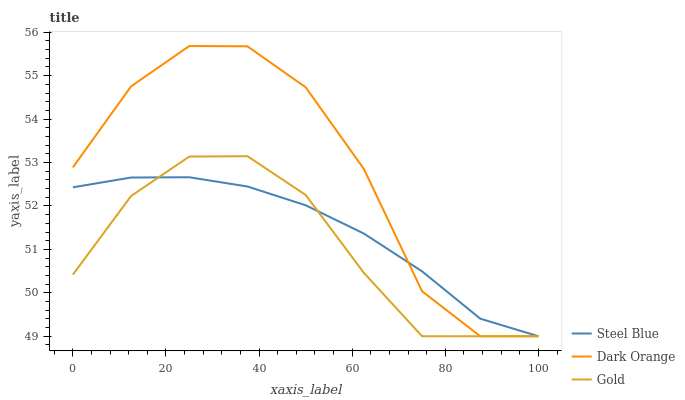Does Gold have the minimum area under the curve?
Answer yes or no. Yes. Does Dark Orange have the maximum area under the curve?
Answer yes or no. Yes. Does Steel Blue have the minimum area under the curve?
Answer yes or no. No. Does Steel Blue have the maximum area under the curve?
Answer yes or no. No. Is Steel Blue the smoothest?
Answer yes or no. Yes. Is Dark Orange the roughest?
Answer yes or no. Yes. Is Gold the smoothest?
Answer yes or no. No. Is Gold the roughest?
Answer yes or no. No. Does Dark Orange have the lowest value?
Answer yes or no. Yes. Does Dark Orange have the highest value?
Answer yes or no. Yes. Does Gold have the highest value?
Answer yes or no. No. Does Steel Blue intersect Dark Orange?
Answer yes or no. Yes. Is Steel Blue less than Dark Orange?
Answer yes or no. No. Is Steel Blue greater than Dark Orange?
Answer yes or no. No. 